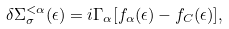Convert formula to latex. <formula><loc_0><loc_0><loc_500><loc_500>\delta \Sigma ^ { < \alpha } _ { \sigma } ( \epsilon ) = i \Gamma _ { \alpha } [ f _ { \alpha } ( \epsilon ) - f _ { C } ( \epsilon ) ] ,</formula> 